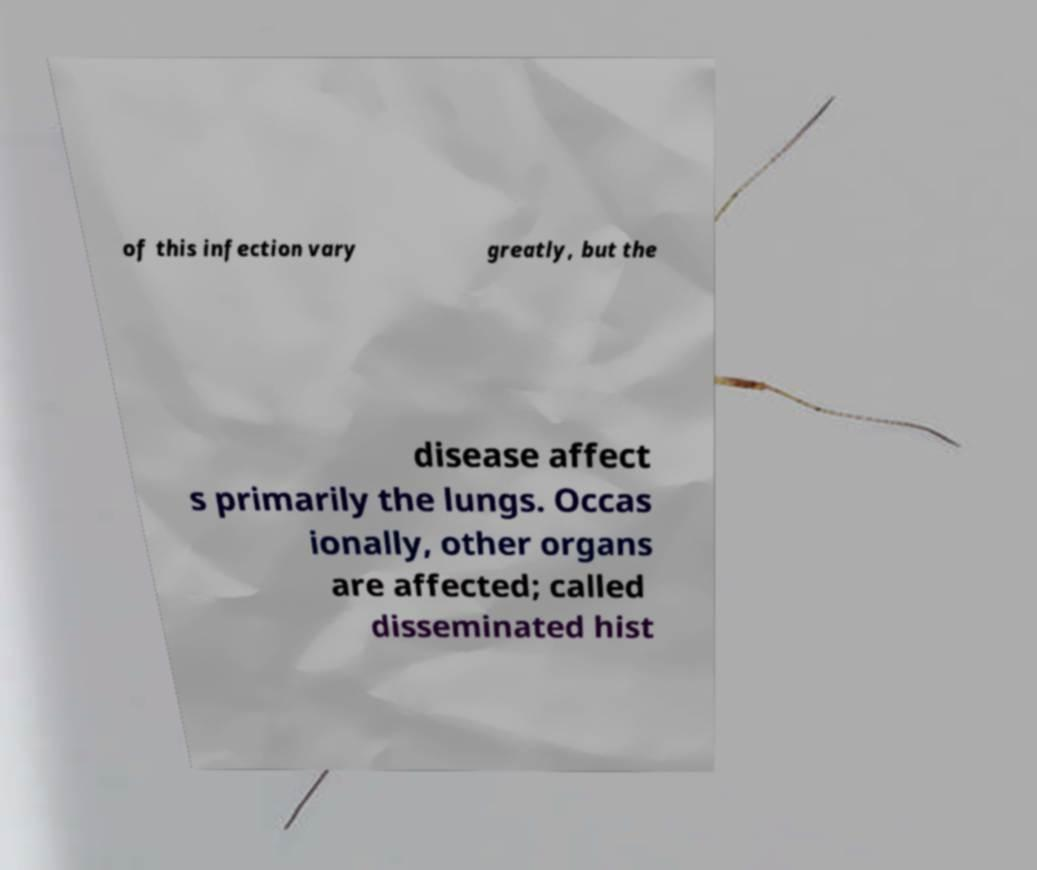There's text embedded in this image that I need extracted. Can you transcribe it verbatim? of this infection vary greatly, but the disease affect s primarily the lungs. Occas ionally, other organs are affected; called disseminated hist 